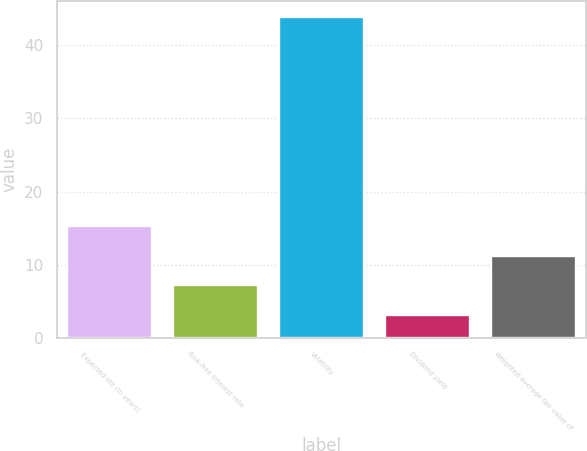Convert chart to OTSL. <chart><loc_0><loc_0><loc_500><loc_500><bar_chart><fcel>Expected life (in years)<fcel>Risk-free interest rate<fcel>Volatility<fcel>Dividend yield<fcel>Weighted average fair value of<nl><fcel>15.32<fcel>7.16<fcel>43.9<fcel>3.08<fcel>11.24<nl></chart> 